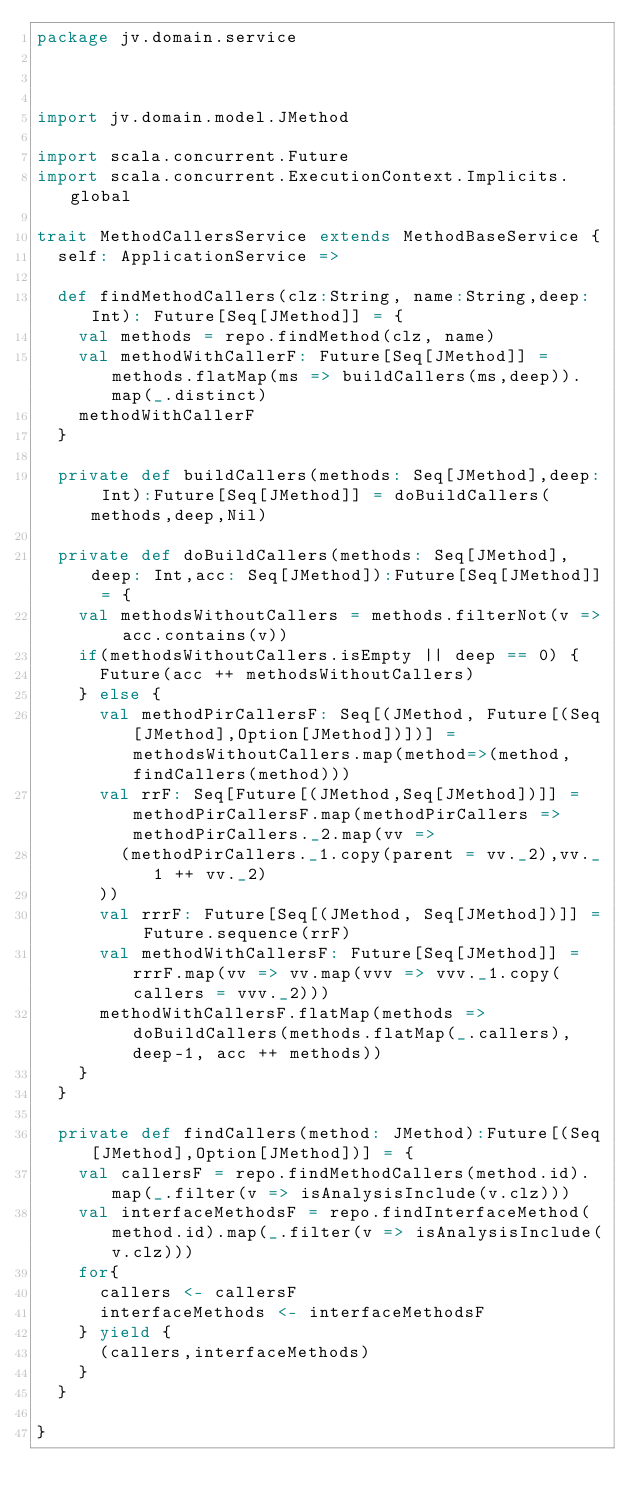<code> <loc_0><loc_0><loc_500><loc_500><_Scala_>package jv.domain.service



import jv.domain.model.JMethod

import scala.concurrent.Future
import scala.concurrent.ExecutionContext.Implicits.global

trait MethodCallersService extends MethodBaseService {
  self: ApplicationService =>

  def findMethodCallers(clz:String, name:String,deep: Int): Future[Seq[JMethod]] = {
    val methods = repo.findMethod(clz, name)
    val methodWithCallerF: Future[Seq[JMethod]] = methods.flatMap(ms => buildCallers(ms,deep)).map(_.distinct)
    methodWithCallerF
  }

  private def buildCallers(methods: Seq[JMethod],deep: Int):Future[Seq[JMethod]] = doBuildCallers(methods,deep,Nil)

  private def doBuildCallers(methods: Seq[JMethod],deep: Int,acc: Seq[JMethod]):Future[Seq[JMethod]] = {
    val methodsWithoutCallers = methods.filterNot(v => acc.contains(v))
    if(methodsWithoutCallers.isEmpty || deep == 0) {
      Future(acc ++ methodsWithoutCallers)
    } else {
      val methodPirCallersF: Seq[(JMethod, Future[(Seq[JMethod],Option[JMethod])])] = methodsWithoutCallers.map(method=>(method,findCallers(method)))
      val rrF: Seq[Future[(JMethod,Seq[JMethod])]] = methodPirCallersF.map(methodPirCallers => methodPirCallers._2.map(vv =>
        (methodPirCallers._1.copy(parent = vv._2),vv._1 ++ vv._2)
      ))
      val rrrF: Future[Seq[(JMethod, Seq[JMethod])]] = Future.sequence(rrF)
      val methodWithCallersF: Future[Seq[JMethod]] = rrrF.map(vv => vv.map(vvv => vvv._1.copy(callers = vvv._2)))
      methodWithCallersF.flatMap(methods => doBuildCallers(methods.flatMap(_.callers),deep-1, acc ++ methods))
    }
  }

  private def findCallers(method: JMethod):Future[(Seq[JMethod],Option[JMethod])] = {
    val callersF = repo.findMethodCallers(method.id).map(_.filter(v => isAnalysisInclude(v.clz)))
    val interfaceMethodsF = repo.findInterfaceMethod(method.id).map(_.filter(v => isAnalysisInclude(v.clz)))
    for{
      callers <- callersF
      interfaceMethods <- interfaceMethodsF
    } yield {
      (callers,interfaceMethods)
    }
  }

}
</code> 